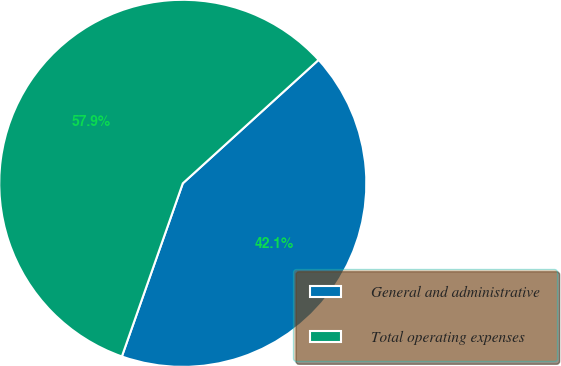Convert chart to OTSL. <chart><loc_0><loc_0><loc_500><loc_500><pie_chart><fcel>General and administrative<fcel>Total operating expenses<nl><fcel>42.13%<fcel>57.87%<nl></chart> 